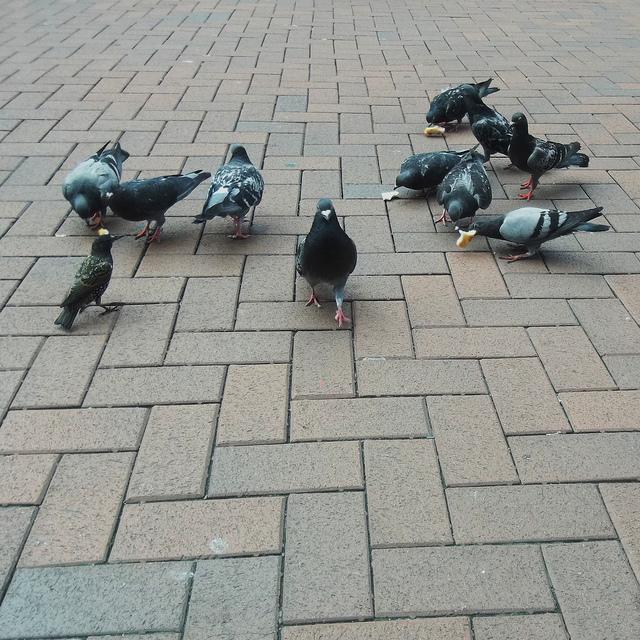How many pigeons are there?
Be succinct. 11. Is someone feeding the pigeons?
Quick response, please. No. Are the pigeons standing on a man-made surface?
Be succinct. Yes. 